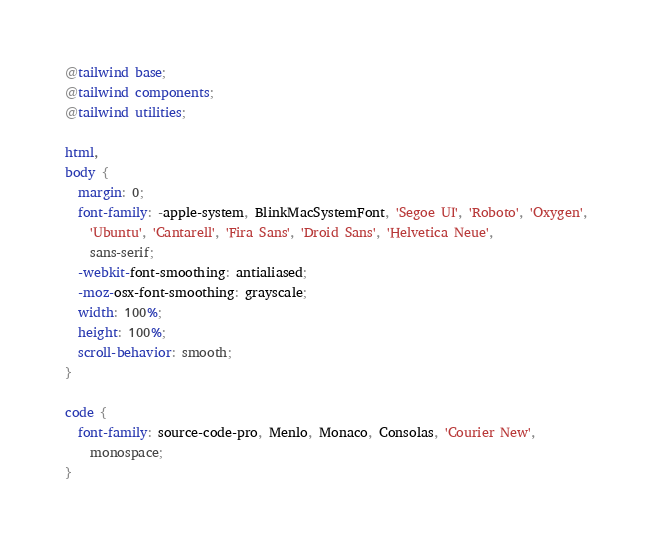Convert code to text. <code><loc_0><loc_0><loc_500><loc_500><_CSS_>@tailwind base;
@tailwind components;
@tailwind utilities;

html,
body {
  margin: 0;
  font-family: -apple-system, BlinkMacSystemFont, 'Segoe UI', 'Roboto', 'Oxygen',
    'Ubuntu', 'Cantarell', 'Fira Sans', 'Droid Sans', 'Helvetica Neue',
    sans-serif;
  -webkit-font-smoothing: antialiased;
  -moz-osx-font-smoothing: grayscale;
  width: 100%;
  height: 100%;
  scroll-behavior: smooth;
}

code {
  font-family: source-code-pro, Menlo, Monaco, Consolas, 'Courier New',
    monospace;
}
</code> 